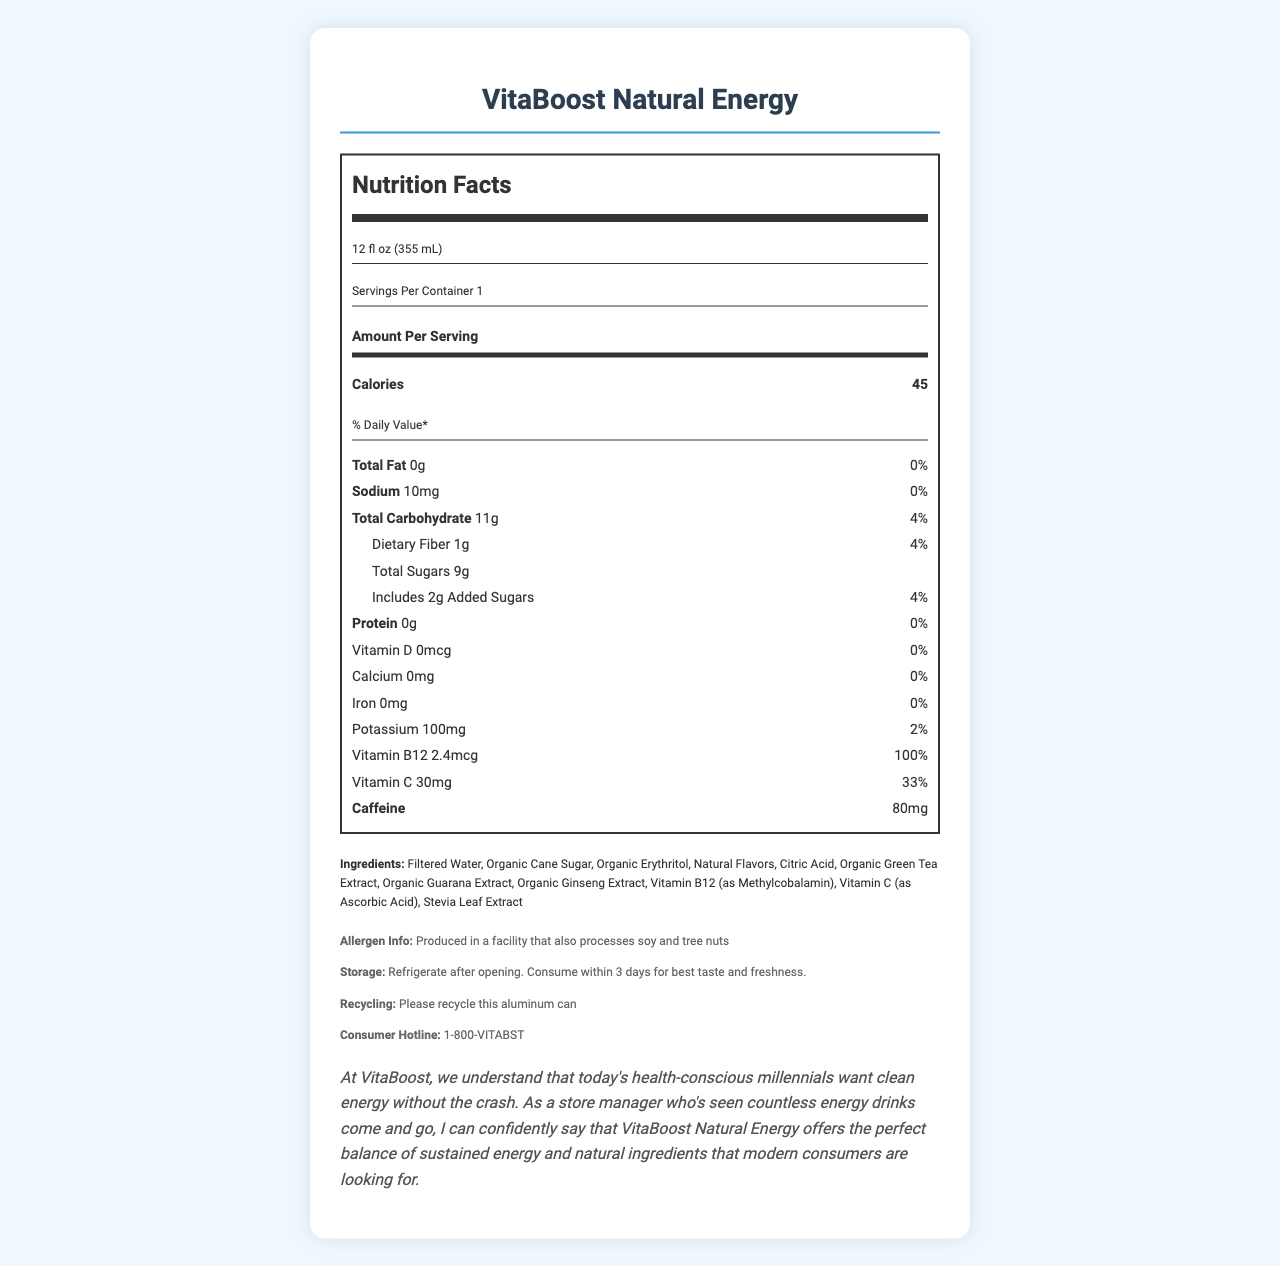what is the serving size? The serving size is stated at the top of the Nutrition Facts section as "12 fl oz (355 mL)".
Answer: 12 fl oz (355 mL) how many calories are in one serving? The document lists the calories per serving as 45.
Answer: 45 what is the amount of sodium per serving? The amount of sodium per serving is listed as 10mg in the Nutrition Facts section.
Answer: 10mg what are the total sugars in one serving? According to the Nutrition Facts, total sugars per serving are 9g.
Answer: 9g what is the main ingredient in VitaBoost Natural Energy? The first ingredient listed is Filtered Water, indicating it is the main ingredient.
Answer: Filtered Water What is the daily value percentage of Vitamin C per serving? The document specifies that each serving provides 33% of the daily value for Vitamin C.
Answer: 33% how much caffeine is in the drink? The drink contains 80mg of caffeine as indicated in the Nutrition Facts.
Answer: 80mg what are the storage instructions for VitaBoost Natural Energy? The storage instructions are listed in the additional info section.
Answer: Refrigerate after opening. Consume within 3 days for best taste and freshness. What type of facility is VitaBoost produced in? A. Dairy B. Soy and Tree Nuts C. Peanut and Gluten The document states that the product is produced in a facility that also processes soy and tree nuts.
Answer: B What is the protein content per serving? A. 2g B. 1g C. 0g D. 5g The Nutrition Facts state that the protein content per serving is 0g.
Answer: C is this energy drink high in total fat? The total fat content per serving is 0g, which is 0% of the daily value, indicating it is not high in total fat.
Answer: No does the drink contain any added sugars? The Nutrition Facts specify that the drink includes 2g of added sugars, which makes up 4% of the daily value.
Answer: Yes Does the document provide the expiration date of the product? The document doesn't provide any information regarding the expiration date of the product.
Answer: Cannot be determined please summarize the main points of the document. The summary covers the key aspects of the document by mentioning the main nutrition facts, ingredients, benefits, intended audience, and additional consumer information.
Answer: The document provides detailed nutrition facts for VitaBoost Natural Energy, an energy drink aimed at health-conscious millennials. It highlights that the drink contains 45 calories per serving, has low sugar content with 9g total sugars, and includes natural ingredients like organic cane sugar, green tea extract, and various vitamins. It contains 80mg of caffeine for an energy boost and provides essential information on allergens, storage instructions, and a manufacturer statement promoting the product’s benefits. what is the daily value percentage of added sugars? For added sugars, the daily value percentage listed is 4% according to the Nutrition Facts.
Answer: 4% 